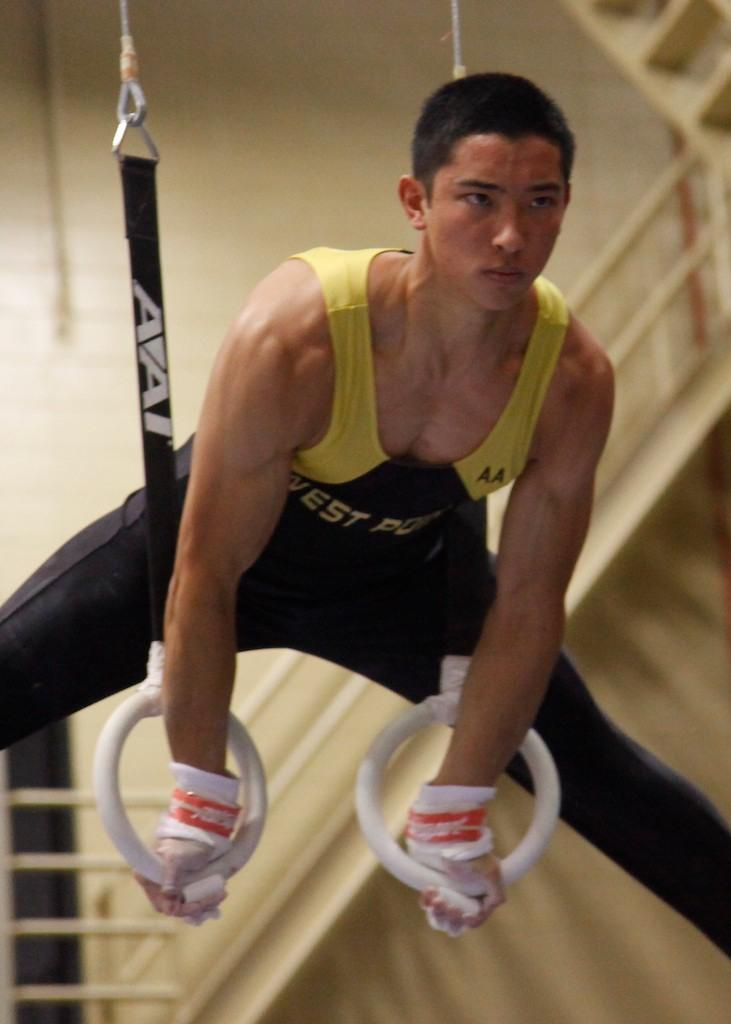<image>
Describe the image concisely. a young muscly man in a West jersey holds himself above some gymnast rings 